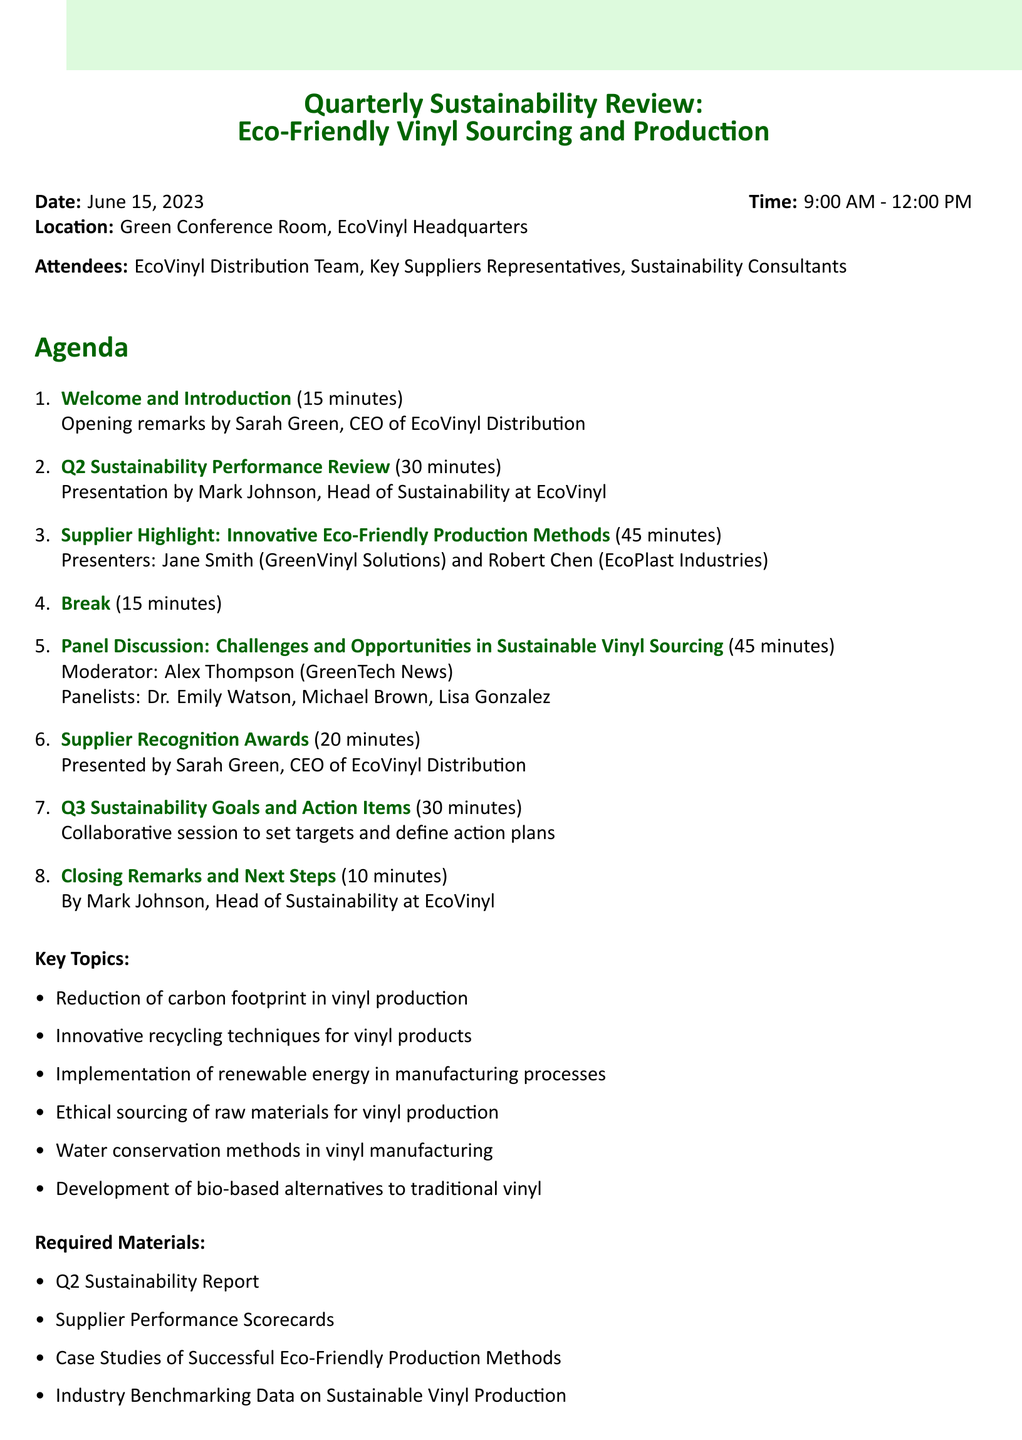what is the date of the meeting? The date of the meeting is mentioned clearly at the beginning of the document.
Answer: June 15, 2023 who is the presenter of the Q2 Sustainability Performance Review? The presenter for this agenda item is specified in the details section.
Answer: Mark Johnson how long is the break scheduled for? The duration of the break is explicitly stated alongside its agenda item.
Answer: 15 minutes who are the panelists in the discussion about sustainable vinyl sourcing? The panelists are listed under the panel discussion section with their titles.
Answer: Dr. Emily Watson, Michael Brown, Lisa Gonzalez what is one of the key topics discussed at the meeting? Key topics are outlined in a list format within the document.
Answer: Reduction of carbon footprint in vinyl production how many minutes are allocated for the Supplier Recognition Awards? The duration for this agenda item is specified directly.
Answer: 20 minutes what is the location of the meeting? The location is mentioned right after the date and time in the document.
Answer: Green Conference Room, EcoVinyl Headquarters what is the role of Sarah Green in the meeting? Sarah Green's role is detailed in the context of her presentations within the agenda.
Answer: CEO of EcoVinyl Distribution 